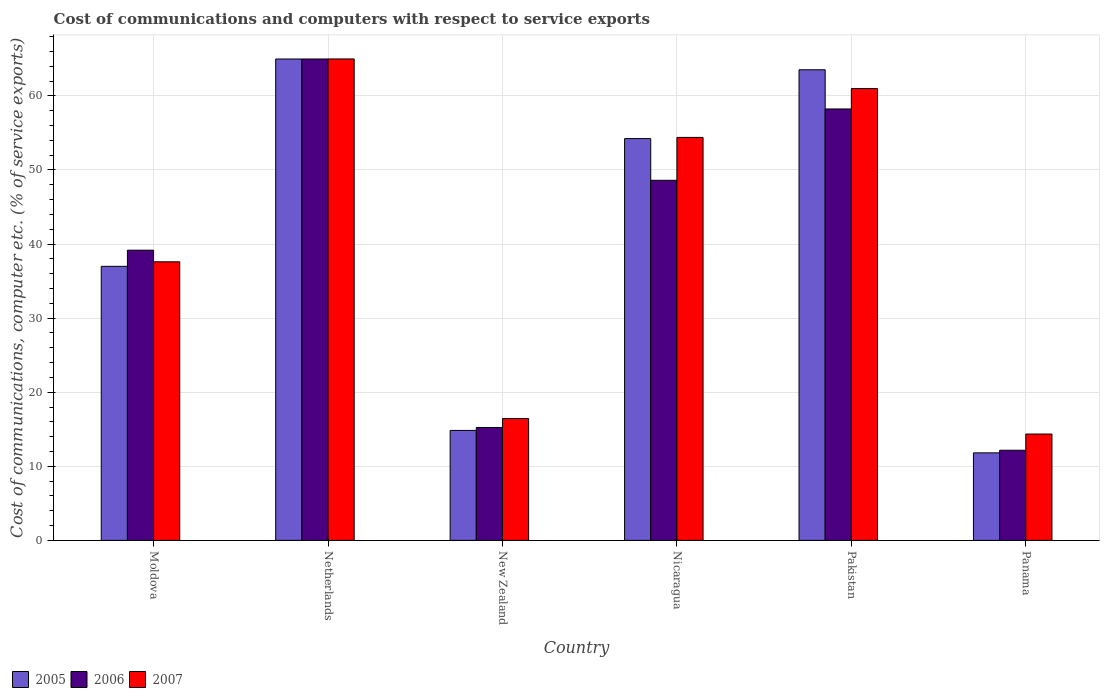How many different coloured bars are there?
Offer a terse response. 3. How many groups of bars are there?
Give a very brief answer. 6. Are the number of bars on each tick of the X-axis equal?
Offer a very short reply. Yes. How many bars are there on the 2nd tick from the left?
Give a very brief answer. 3. What is the label of the 4th group of bars from the left?
Keep it short and to the point. Nicaragua. In how many cases, is the number of bars for a given country not equal to the number of legend labels?
Make the answer very short. 0. What is the cost of communications and computers in 2007 in Panama?
Keep it short and to the point. 14.35. Across all countries, what is the maximum cost of communications and computers in 2005?
Offer a terse response. 64.97. Across all countries, what is the minimum cost of communications and computers in 2006?
Your answer should be compact. 12.17. In which country was the cost of communications and computers in 2005 minimum?
Provide a short and direct response. Panama. What is the total cost of communications and computers in 2005 in the graph?
Offer a terse response. 246.36. What is the difference between the cost of communications and computers in 2006 in Moldova and that in Panama?
Keep it short and to the point. 27. What is the difference between the cost of communications and computers in 2007 in Nicaragua and the cost of communications and computers in 2005 in Panama?
Make the answer very short. 42.57. What is the average cost of communications and computers in 2005 per country?
Your answer should be very brief. 41.06. What is the difference between the cost of communications and computers of/in 2006 and cost of communications and computers of/in 2005 in Nicaragua?
Offer a terse response. -5.63. In how many countries, is the cost of communications and computers in 2006 greater than 12 %?
Ensure brevity in your answer.  6. What is the ratio of the cost of communications and computers in 2006 in New Zealand to that in Panama?
Offer a terse response. 1.25. Is the difference between the cost of communications and computers in 2006 in Moldova and Netherlands greater than the difference between the cost of communications and computers in 2005 in Moldova and Netherlands?
Offer a very short reply. Yes. What is the difference between the highest and the second highest cost of communications and computers in 2007?
Your response must be concise. 4. What is the difference between the highest and the lowest cost of communications and computers in 2006?
Your answer should be very brief. 52.81. What does the 2nd bar from the right in Nicaragua represents?
Provide a short and direct response. 2006. How many bars are there?
Your answer should be compact. 18. Are all the bars in the graph horizontal?
Your response must be concise. No. Does the graph contain any zero values?
Your answer should be compact. No. Does the graph contain grids?
Your answer should be compact. Yes. What is the title of the graph?
Offer a very short reply. Cost of communications and computers with respect to service exports. What is the label or title of the X-axis?
Make the answer very short. Country. What is the label or title of the Y-axis?
Provide a short and direct response. Cost of communications, computer etc. (% of service exports). What is the Cost of communications, computer etc. (% of service exports) in 2005 in Moldova?
Ensure brevity in your answer.  36.99. What is the Cost of communications, computer etc. (% of service exports) of 2006 in Moldova?
Give a very brief answer. 39.17. What is the Cost of communications, computer etc. (% of service exports) of 2007 in Moldova?
Your answer should be very brief. 37.6. What is the Cost of communications, computer etc. (% of service exports) of 2005 in Netherlands?
Your response must be concise. 64.97. What is the Cost of communications, computer etc. (% of service exports) of 2006 in Netherlands?
Provide a succinct answer. 64.97. What is the Cost of communications, computer etc. (% of service exports) of 2007 in Netherlands?
Your response must be concise. 64.98. What is the Cost of communications, computer etc. (% of service exports) in 2005 in New Zealand?
Your answer should be very brief. 14.84. What is the Cost of communications, computer etc. (% of service exports) of 2006 in New Zealand?
Offer a terse response. 15.24. What is the Cost of communications, computer etc. (% of service exports) in 2007 in New Zealand?
Keep it short and to the point. 16.44. What is the Cost of communications, computer etc. (% of service exports) of 2005 in Nicaragua?
Your answer should be compact. 54.23. What is the Cost of communications, computer etc. (% of service exports) in 2006 in Nicaragua?
Keep it short and to the point. 48.6. What is the Cost of communications, computer etc. (% of service exports) in 2007 in Nicaragua?
Make the answer very short. 54.39. What is the Cost of communications, computer etc. (% of service exports) of 2005 in Pakistan?
Your answer should be compact. 63.52. What is the Cost of communications, computer etc. (% of service exports) of 2006 in Pakistan?
Offer a terse response. 58.23. What is the Cost of communications, computer etc. (% of service exports) of 2007 in Pakistan?
Provide a short and direct response. 60.98. What is the Cost of communications, computer etc. (% of service exports) in 2005 in Panama?
Provide a succinct answer. 11.81. What is the Cost of communications, computer etc. (% of service exports) in 2006 in Panama?
Provide a short and direct response. 12.17. What is the Cost of communications, computer etc. (% of service exports) in 2007 in Panama?
Your answer should be compact. 14.35. Across all countries, what is the maximum Cost of communications, computer etc. (% of service exports) in 2005?
Provide a short and direct response. 64.97. Across all countries, what is the maximum Cost of communications, computer etc. (% of service exports) of 2006?
Make the answer very short. 64.97. Across all countries, what is the maximum Cost of communications, computer etc. (% of service exports) of 2007?
Offer a terse response. 64.98. Across all countries, what is the minimum Cost of communications, computer etc. (% of service exports) in 2005?
Keep it short and to the point. 11.81. Across all countries, what is the minimum Cost of communications, computer etc. (% of service exports) of 2006?
Ensure brevity in your answer.  12.17. Across all countries, what is the minimum Cost of communications, computer etc. (% of service exports) of 2007?
Make the answer very short. 14.35. What is the total Cost of communications, computer etc. (% of service exports) in 2005 in the graph?
Your answer should be compact. 246.36. What is the total Cost of communications, computer etc. (% of service exports) in 2006 in the graph?
Your answer should be very brief. 238.37. What is the total Cost of communications, computer etc. (% of service exports) in 2007 in the graph?
Offer a terse response. 248.74. What is the difference between the Cost of communications, computer etc. (% of service exports) in 2005 in Moldova and that in Netherlands?
Your response must be concise. -27.98. What is the difference between the Cost of communications, computer etc. (% of service exports) in 2006 in Moldova and that in Netherlands?
Give a very brief answer. -25.81. What is the difference between the Cost of communications, computer etc. (% of service exports) in 2007 in Moldova and that in Netherlands?
Give a very brief answer. -27.38. What is the difference between the Cost of communications, computer etc. (% of service exports) of 2005 in Moldova and that in New Zealand?
Your response must be concise. 22.15. What is the difference between the Cost of communications, computer etc. (% of service exports) of 2006 in Moldova and that in New Zealand?
Give a very brief answer. 23.93. What is the difference between the Cost of communications, computer etc. (% of service exports) in 2007 in Moldova and that in New Zealand?
Make the answer very short. 21.16. What is the difference between the Cost of communications, computer etc. (% of service exports) of 2005 in Moldova and that in Nicaragua?
Offer a terse response. -17.24. What is the difference between the Cost of communications, computer etc. (% of service exports) of 2006 in Moldova and that in Nicaragua?
Provide a succinct answer. -9.43. What is the difference between the Cost of communications, computer etc. (% of service exports) of 2007 in Moldova and that in Nicaragua?
Ensure brevity in your answer.  -16.79. What is the difference between the Cost of communications, computer etc. (% of service exports) in 2005 in Moldova and that in Pakistan?
Make the answer very short. -26.53. What is the difference between the Cost of communications, computer etc. (% of service exports) of 2006 in Moldova and that in Pakistan?
Your answer should be compact. -19.06. What is the difference between the Cost of communications, computer etc. (% of service exports) in 2007 in Moldova and that in Pakistan?
Provide a short and direct response. -23.38. What is the difference between the Cost of communications, computer etc. (% of service exports) of 2005 in Moldova and that in Panama?
Ensure brevity in your answer.  25.17. What is the difference between the Cost of communications, computer etc. (% of service exports) in 2006 in Moldova and that in Panama?
Make the answer very short. 27. What is the difference between the Cost of communications, computer etc. (% of service exports) of 2007 in Moldova and that in Panama?
Your answer should be very brief. 23.25. What is the difference between the Cost of communications, computer etc. (% of service exports) of 2005 in Netherlands and that in New Zealand?
Your answer should be compact. 50.13. What is the difference between the Cost of communications, computer etc. (% of service exports) in 2006 in Netherlands and that in New Zealand?
Ensure brevity in your answer.  49.73. What is the difference between the Cost of communications, computer etc. (% of service exports) in 2007 in Netherlands and that in New Zealand?
Give a very brief answer. 48.54. What is the difference between the Cost of communications, computer etc. (% of service exports) in 2005 in Netherlands and that in Nicaragua?
Keep it short and to the point. 10.74. What is the difference between the Cost of communications, computer etc. (% of service exports) of 2006 in Netherlands and that in Nicaragua?
Give a very brief answer. 16.37. What is the difference between the Cost of communications, computer etc. (% of service exports) in 2007 in Netherlands and that in Nicaragua?
Provide a succinct answer. 10.59. What is the difference between the Cost of communications, computer etc. (% of service exports) in 2005 in Netherlands and that in Pakistan?
Keep it short and to the point. 1.45. What is the difference between the Cost of communications, computer etc. (% of service exports) in 2006 in Netherlands and that in Pakistan?
Provide a short and direct response. 6.75. What is the difference between the Cost of communications, computer etc. (% of service exports) of 2007 in Netherlands and that in Pakistan?
Give a very brief answer. 4. What is the difference between the Cost of communications, computer etc. (% of service exports) in 2005 in Netherlands and that in Panama?
Offer a terse response. 53.16. What is the difference between the Cost of communications, computer etc. (% of service exports) in 2006 in Netherlands and that in Panama?
Your response must be concise. 52.81. What is the difference between the Cost of communications, computer etc. (% of service exports) of 2007 in Netherlands and that in Panama?
Keep it short and to the point. 50.62. What is the difference between the Cost of communications, computer etc. (% of service exports) in 2005 in New Zealand and that in Nicaragua?
Provide a succinct answer. -39.39. What is the difference between the Cost of communications, computer etc. (% of service exports) of 2006 in New Zealand and that in Nicaragua?
Ensure brevity in your answer.  -33.36. What is the difference between the Cost of communications, computer etc. (% of service exports) of 2007 in New Zealand and that in Nicaragua?
Provide a succinct answer. -37.95. What is the difference between the Cost of communications, computer etc. (% of service exports) in 2005 in New Zealand and that in Pakistan?
Make the answer very short. -48.68. What is the difference between the Cost of communications, computer etc. (% of service exports) of 2006 in New Zealand and that in Pakistan?
Make the answer very short. -42.99. What is the difference between the Cost of communications, computer etc. (% of service exports) in 2007 in New Zealand and that in Pakistan?
Offer a terse response. -44.54. What is the difference between the Cost of communications, computer etc. (% of service exports) in 2005 in New Zealand and that in Panama?
Offer a terse response. 3.03. What is the difference between the Cost of communications, computer etc. (% of service exports) of 2006 in New Zealand and that in Panama?
Offer a terse response. 3.07. What is the difference between the Cost of communications, computer etc. (% of service exports) in 2007 in New Zealand and that in Panama?
Keep it short and to the point. 2.09. What is the difference between the Cost of communications, computer etc. (% of service exports) in 2005 in Nicaragua and that in Pakistan?
Keep it short and to the point. -9.29. What is the difference between the Cost of communications, computer etc. (% of service exports) in 2006 in Nicaragua and that in Pakistan?
Offer a terse response. -9.63. What is the difference between the Cost of communications, computer etc. (% of service exports) of 2007 in Nicaragua and that in Pakistan?
Offer a terse response. -6.6. What is the difference between the Cost of communications, computer etc. (% of service exports) of 2005 in Nicaragua and that in Panama?
Your answer should be very brief. 42.42. What is the difference between the Cost of communications, computer etc. (% of service exports) in 2006 in Nicaragua and that in Panama?
Provide a succinct answer. 36.43. What is the difference between the Cost of communications, computer etc. (% of service exports) of 2007 in Nicaragua and that in Panama?
Provide a succinct answer. 40.03. What is the difference between the Cost of communications, computer etc. (% of service exports) in 2005 in Pakistan and that in Panama?
Ensure brevity in your answer.  51.71. What is the difference between the Cost of communications, computer etc. (% of service exports) of 2006 in Pakistan and that in Panama?
Your response must be concise. 46.06. What is the difference between the Cost of communications, computer etc. (% of service exports) of 2007 in Pakistan and that in Panama?
Provide a short and direct response. 46.63. What is the difference between the Cost of communications, computer etc. (% of service exports) in 2005 in Moldova and the Cost of communications, computer etc. (% of service exports) in 2006 in Netherlands?
Keep it short and to the point. -27.99. What is the difference between the Cost of communications, computer etc. (% of service exports) in 2005 in Moldova and the Cost of communications, computer etc. (% of service exports) in 2007 in Netherlands?
Keep it short and to the point. -27.99. What is the difference between the Cost of communications, computer etc. (% of service exports) in 2006 in Moldova and the Cost of communications, computer etc. (% of service exports) in 2007 in Netherlands?
Your answer should be very brief. -25.81. What is the difference between the Cost of communications, computer etc. (% of service exports) in 2005 in Moldova and the Cost of communications, computer etc. (% of service exports) in 2006 in New Zealand?
Your answer should be compact. 21.75. What is the difference between the Cost of communications, computer etc. (% of service exports) of 2005 in Moldova and the Cost of communications, computer etc. (% of service exports) of 2007 in New Zealand?
Ensure brevity in your answer.  20.55. What is the difference between the Cost of communications, computer etc. (% of service exports) in 2006 in Moldova and the Cost of communications, computer etc. (% of service exports) in 2007 in New Zealand?
Your response must be concise. 22.73. What is the difference between the Cost of communications, computer etc. (% of service exports) of 2005 in Moldova and the Cost of communications, computer etc. (% of service exports) of 2006 in Nicaragua?
Provide a short and direct response. -11.61. What is the difference between the Cost of communications, computer etc. (% of service exports) of 2005 in Moldova and the Cost of communications, computer etc. (% of service exports) of 2007 in Nicaragua?
Offer a terse response. -17.4. What is the difference between the Cost of communications, computer etc. (% of service exports) in 2006 in Moldova and the Cost of communications, computer etc. (% of service exports) in 2007 in Nicaragua?
Provide a short and direct response. -15.22. What is the difference between the Cost of communications, computer etc. (% of service exports) in 2005 in Moldova and the Cost of communications, computer etc. (% of service exports) in 2006 in Pakistan?
Offer a terse response. -21.24. What is the difference between the Cost of communications, computer etc. (% of service exports) of 2005 in Moldova and the Cost of communications, computer etc. (% of service exports) of 2007 in Pakistan?
Your response must be concise. -24. What is the difference between the Cost of communications, computer etc. (% of service exports) of 2006 in Moldova and the Cost of communications, computer etc. (% of service exports) of 2007 in Pakistan?
Offer a very short reply. -21.82. What is the difference between the Cost of communications, computer etc. (% of service exports) in 2005 in Moldova and the Cost of communications, computer etc. (% of service exports) in 2006 in Panama?
Provide a short and direct response. 24.82. What is the difference between the Cost of communications, computer etc. (% of service exports) in 2005 in Moldova and the Cost of communications, computer etc. (% of service exports) in 2007 in Panama?
Your response must be concise. 22.63. What is the difference between the Cost of communications, computer etc. (% of service exports) of 2006 in Moldova and the Cost of communications, computer etc. (% of service exports) of 2007 in Panama?
Provide a short and direct response. 24.81. What is the difference between the Cost of communications, computer etc. (% of service exports) in 2005 in Netherlands and the Cost of communications, computer etc. (% of service exports) in 2006 in New Zealand?
Keep it short and to the point. 49.73. What is the difference between the Cost of communications, computer etc. (% of service exports) in 2005 in Netherlands and the Cost of communications, computer etc. (% of service exports) in 2007 in New Zealand?
Provide a short and direct response. 48.53. What is the difference between the Cost of communications, computer etc. (% of service exports) in 2006 in Netherlands and the Cost of communications, computer etc. (% of service exports) in 2007 in New Zealand?
Your answer should be compact. 48.53. What is the difference between the Cost of communications, computer etc. (% of service exports) of 2005 in Netherlands and the Cost of communications, computer etc. (% of service exports) of 2006 in Nicaragua?
Give a very brief answer. 16.37. What is the difference between the Cost of communications, computer etc. (% of service exports) in 2005 in Netherlands and the Cost of communications, computer etc. (% of service exports) in 2007 in Nicaragua?
Give a very brief answer. 10.58. What is the difference between the Cost of communications, computer etc. (% of service exports) of 2006 in Netherlands and the Cost of communications, computer etc. (% of service exports) of 2007 in Nicaragua?
Offer a terse response. 10.59. What is the difference between the Cost of communications, computer etc. (% of service exports) in 2005 in Netherlands and the Cost of communications, computer etc. (% of service exports) in 2006 in Pakistan?
Your response must be concise. 6.74. What is the difference between the Cost of communications, computer etc. (% of service exports) of 2005 in Netherlands and the Cost of communications, computer etc. (% of service exports) of 2007 in Pakistan?
Your answer should be very brief. 3.99. What is the difference between the Cost of communications, computer etc. (% of service exports) of 2006 in Netherlands and the Cost of communications, computer etc. (% of service exports) of 2007 in Pakistan?
Your answer should be very brief. 3.99. What is the difference between the Cost of communications, computer etc. (% of service exports) in 2005 in Netherlands and the Cost of communications, computer etc. (% of service exports) in 2006 in Panama?
Your response must be concise. 52.81. What is the difference between the Cost of communications, computer etc. (% of service exports) of 2005 in Netherlands and the Cost of communications, computer etc. (% of service exports) of 2007 in Panama?
Offer a very short reply. 50.62. What is the difference between the Cost of communications, computer etc. (% of service exports) of 2006 in Netherlands and the Cost of communications, computer etc. (% of service exports) of 2007 in Panama?
Your response must be concise. 50.62. What is the difference between the Cost of communications, computer etc. (% of service exports) in 2005 in New Zealand and the Cost of communications, computer etc. (% of service exports) in 2006 in Nicaragua?
Your response must be concise. -33.76. What is the difference between the Cost of communications, computer etc. (% of service exports) of 2005 in New Zealand and the Cost of communications, computer etc. (% of service exports) of 2007 in Nicaragua?
Your answer should be very brief. -39.55. What is the difference between the Cost of communications, computer etc. (% of service exports) in 2006 in New Zealand and the Cost of communications, computer etc. (% of service exports) in 2007 in Nicaragua?
Your answer should be very brief. -39.15. What is the difference between the Cost of communications, computer etc. (% of service exports) in 2005 in New Zealand and the Cost of communications, computer etc. (% of service exports) in 2006 in Pakistan?
Offer a terse response. -43.39. What is the difference between the Cost of communications, computer etc. (% of service exports) of 2005 in New Zealand and the Cost of communications, computer etc. (% of service exports) of 2007 in Pakistan?
Provide a succinct answer. -46.14. What is the difference between the Cost of communications, computer etc. (% of service exports) of 2006 in New Zealand and the Cost of communications, computer etc. (% of service exports) of 2007 in Pakistan?
Give a very brief answer. -45.74. What is the difference between the Cost of communications, computer etc. (% of service exports) in 2005 in New Zealand and the Cost of communications, computer etc. (% of service exports) in 2006 in Panama?
Offer a terse response. 2.68. What is the difference between the Cost of communications, computer etc. (% of service exports) in 2005 in New Zealand and the Cost of communications, computer etc. (% of service exports) in 2007 in Panama?
Your answer should be compact. 0.49. What is the difference between the Cost of communications, computer etc. (% of service exports) of 2006 in New Zealand and the Cost of communications, computer etc. (% of service exports) of 2007 in Panama?
Offer a very short reply. 0.89. What is the difference between the Cost of communications, computer etc. (% of service exports) in 2005 in Nicaragua and the Cost of communications, computer etc. (% of service exports) in 2006 in Pakistan?
Provide a short and direct response. -4. What is the difference between the Cost of communications, computer etc. (% of service exports) of 2005 in Nicaragua and the Cost of communications, computer etc. (% of service exports) of 2007 in Pakistan?
Keep it short and to the point. -6.75. What is the difference between the Cost of communications, computer etc. (% of service exports) in 2006 in Nicaragua and the Cost of communications, computer etc. (% of service exports) in 2007 in Pakistan?
Your response must be concise. -12.38. What is the difference between the Cost of communications, computer etc. (% of service exports) of 2005 in Nicaragua and the Cost of communications, computer etc. (% of service exports) of 2006 in Panama?
Your response must be concise. 42.06. What is the difference between the Cost of communications, computer etc. (% of service exports) in 2005 in Nicaragua and the Cost of communications, computer etc. (% of service exports) in 2007 in Panama?
Offer a very short reply. 39.88. What is the difference between the Cost of communications, computer etc. (% of service exports) in 2006 in Nicaragua and the Cost of communications, computer etc. (% of service exports) in 2007 in Panama?
Keep it short and to the point. 34.24. What is the difference between the Cost of communications, computer etc. (% of service exports) in 2005 in Pakistan and the Cost of communications, computer etc. (% of service exports) in 2006 in Panama?
Ensure brevity in your answer.  51.35. What is the difference between the Cost of communications, computer etc. (% of service exports) in 2005 in Pakistan and the Cost of communications, computer etc. (% of service exports) in 2007 in Panama?
Your answer should be very brief. 49.17. What is the difference between the Cost of communications, computer etc. (% of service exports) in 2006 in Pakistan and the Cost of communications, computer etc. (% of service exports) in 2007 in Panama?
Give a very brief answer. 43.87. What is the average Cost of communications, computer etc. (% of service exports) of 2005 per country?
Make the answer very short. 41.06. What is the average Cost of communications, computer etc. (% of service exports) in 2006 per country?
Offer a very short reply. 39.73. What is the average Cost of communications, computer etc. (% of service exports) in 2007 per country?
Your answer should be very brief. 41.46. What is the difference between the Cost of communications, computer etc. (% of service exports) of 2005 and Cost of communications, computer etc. (% of service exports) of 2006 in Moldova?
Provide a succinct answer. -2.18. What is the difference between the Cost of communications, computer etc. (% of service exports) in 2005 and Cost of communications, computer etc. (% of service exports) in 2007 in Moldova?
Ensure brevity in your answer.  -0.61. What is the difference between the Cost of communications, computer etc. (% of service exports) of 2006 and Cost of communications, computer etc. (% of service exports) of 2007 in Moldova?
Your answer should be very brief. 1.57. What is the difference between the Cost of communications, computer etc. (% of service exports) in 2005 and Cost of communications, computer etc. (% of service exports) in 2006 in Netherlands?
Give a very brief answer. -0. What is the difference between the Cost of communications, computer etc. (% of service exports) of 2005 and Cost of communications, computer etc. (% of service exports) of 2007 in Netherlands?
Give a very brief answer. -0.01. What is the difference between the Cost of communications, computer etc. (% of service exports) of 2006 and Cost of communications, computer etc. (% of service exports) of 2007 in Netherlands?
Provide a succinct answer. -0.01. What is the difference between the Cost of communications, computer etc. (% of service exports) in 2005 and Cost of communications, computer etc. (% of service exports) in 2006 in New Zealand?
Your response must be concise. -0.4. What is the difference between the Cost of communications, computer etc. (% of service exports) of 2005 and Cost of communications, computer etc. (% of service exports) of 2007 in New Zealand?
Provide a succinct answer. -1.6. What is the difference between the Cost of communications, computer etc. (% of service exports) of 2006 and Cost of communications, computer etc. (% of service exports) of 2007 in New Zealand?
Provide a short and direct response. -1.2. What is the difference between the Cost of communications, computer etc. (% of service exports) in 2005 and Cost of communications, computer etc. (% of service exports) in 2006 in Nicaragua?
Make the answer very short. 5.63. What is the difference between the Cost of communications, computer etc. (% of service exports) in 2005 and Cost of communications, computer etc. (% of service exports) in 2007 in Nicaragua?
Your answer should be very brief. -0.16. What is the difference between the Cost of communications, computer etc. (% of service exports) of 2006 and Cost of communications, computer etc. (% of service exports) of 2007 in Nicaragua?
Offer a terse response. -5.79. What is the difference between the Cost of communications, computer etc. (% of service exports) in 2005 and Cost of communications, computer etc. (% of service exports) in 2006 in Pakistan?
Offer a terse response. 5.29. What is the difference between the Cost of communications, computer etc. (% of service exports) in 2005 and Cost of communications, computer etc. (% of service exports) in 2007 in Pakistan?
Offer a very short reply. 2.54. What is the difference between the Cost of communications, computer etc. (% of service exports) in 2006 and Cost of communications, computer etc. (% of service exports) in 2007 in Pakistan?
Your response must be concise. -2.76. What is the difference between the Cost of communications, computer etc. (% of service exports) in 2005 and Cost of communications, computer etc. (% of service exports) in 2006 in Panama?
Offer a terse response. -0.35. What is the difference between the Cost of communications, computer etc. (% of service exports) in 2005 and Cost of communications, computer etc. (% of service exports) in 2007 in Panama?
Your response must be concise. -2.54. What is the difference between the Cost of communications, computer etc. (% of service exports) of 2006 and Cost of communications, computer etc. (% of service exports) of 2007 in Panama?
Your response must be concise. -2.19. What is the ratio of the Cost of communications, computer etc. (% of service exports) in 2005 in Moldova to that in Netherlands?
Give a very brief answer. 0.57. What is the ratio of the Cost of communications, computer etc. (% of service exports) in 2006 in Moldova to that in Netherlands?
Your answer should be compact. 0.6. What is the ratio of the Cost of communications, computer etc. (% of service exports) in 2007 in Moldova to that in Netherlands?
Offer a very short reply. 0.58. What is the ratio of the Cost of communications, computer etc. (% of service exports) in 2005 in Moldova to that in New Zealand?
Make the answer very short. 2.49. What is the ratio of the Cost of communications, computer etc. (% of service exports) of 2006 in Moldova to that in New Zealand?
Provide a short and direct response. 2.57. What is the ratio of the Cost of communications, computer etc. (% of service exports) in 2007 in Moldova to that in New Zealand?
Your answer should be very brief. 2.29. What is the ratio of the Cost of communications, computer etc. (% of service exports) of 2005 in Moldova to that in Nicaragua?
Your answer should be compact. 0.68. What is the ratio of the Cost of communications, computer etc. (% of service exports) in 2006 in Moldova to that in Nicaragua?
Keep it short and to the point. 0.81. What is the ratio of the Cost of communications, computer etc. (% of service exports) of 2007 in Moldova to that in Nicaragua?
Provide a short and direct response. 0.69. What is the ratio of the Cost of communications, computer etc. (% of service exports) in 2005 in Moldova to that in Pakistan?
Keep it short and to the point. 0.58. What is the ratio of the Cost of communications, computer etc. (% of service exports) in 2006 in Moldova to that in Pakistan?
Your response must be concise. 0.67. What is the ratio of the Cost of communications, computer etc. (% of service exports) in 2007 in Moldova to that in Pakistan?
Provide a succinct answer. 0.62. What is the ratio of the Cost of communications, computer etc. (% of service exports) in 2005 in Moldova to that in Panama?
Offer a very short reply. 3.13. What is the ratio of the Cost of communications, computer etc. (% of service exports) of 2006 in Moldova to that in Panama?
Your answer should be compact. 3.22. What is the ratio of the Cost of communications, computer etc. (% of service exports) in 2007 in Moldova to that in Panama?
Give a very brief answer. 2.62. What is the ratio of the Cost of communications, computer etc. (% of service exports) of 2005 in Netherlands to that in New Zealand?
Offer a terse response. 4.38. What is the ratio of the Cost of communications, computer etc. (% of service exports) of 2006 in Netherlands to that in New Zealand?
Provide a short and direct response. 4.26. What is the ratio of the Cost of communications, computer etc. (% of service exports) of 2007 in Netherlands to that in New Zealand?
Your response must be concise. 3.95. What is the ratio of the Cost of communications, computer etc. (% of service exports) in 2005 in Netherlands to that in Nicaragua?
Provide a succinct answer. 1.2. What is the ratio of the Cost of communications, computer etc. (% of service exports) in 2006 in Netherlands to that in Nicaragua?
Ensure brevity in your answer.  1.34. What is the ratio of the Cost of communications, computer etc. (% of service exports) in 2007 in Netherlands to that in Nicaragua?
Keep it short and to the point. 1.19. What is the ratio of the Cost of communications, computer etc. (% of service exports) of 2005 in Netherlands to that in Pakistan?
Your answer should be very brief. 1.02. What is the ratio of the Cost of communications, computer etc. (% of service exports) in 2006 in Netherlands to that in Pakistan?
Ensure brevity in your answer.  1.12. What is the ratio of the Cost of communications, computer etc. (% of service exports) in 2007 in Netherlands to that in Pakistan?
Your answer should be compact. 1.07. What is the ratio of the Cost of communications, computer etc. (% of service exports) of 2005 in Netherlands to that in Panama?
Your response must be concise. 5.5. What is the ratio of the Cost of communications, computer etc. (% of service exports) in 2006 in Netherlands to that in Panama?
Make the answer very short. 5.34. What is the ratio of the Cost of communications, computer etc. (% of service exports) of 2007 in Netherlands to that in Panama?
Make the answer very short. 4.53. What is the ratio of the Cost of communications, computer etc. (% of service exports) of 2005 in New Zealand to that in Nicaragua?
Your answer should be compact. 0.27. What is the ratio of the Cost of communications, computer etc. (% of service exports) of 2006 in New Zealand to that in Nicaragua?
Your answer should be compact. 0.31. What is the ratio of the Cost of communications, computer etc. (% of service exports) in 2007 in New Zealand to that in Nicaragua?
Keep it short and to the point. 0.3. What is the ratio of the Cost of communications, computer etc. (% of service exports) of 2005 in New Zealand to that in Pakistan?
Provide a succinct answer. 0.23. What is the ratio of the Cost of communications, computer etc. (% of service exports) in 2006 in New Zealand to that in Pakistan?
Provide a short and direct response. 0.26. What is the ratio of the Cost of communications, computer etc. (% of service exports) in 2007 in New Zealand to that in Pakistan?
Give a very brief answer. 0.27. What is the ratio of the Cost of communications, computer etc. (% of service exports) in 2005 in New Zealand to that in Panama?
Provide a short and direct response. 1.26. What is the ratio of the Cost of communications, computer etc. (% of service exports) in 2006 in New Zealand to that in Panama?
Keep it short and to the point. 1.25. What is the ratio of the Cost of communications, computer etc. (% of service exports) in 2007 in New Zealand to that in Panama?
Your answer should be very brief. 1.15. What is the ratio of the Cost of communications, computer etc. (% of service exports) of 2005 in Nicaragua to that in Pakistan?
Make the answer very short. 0.85. What is the ratio of the Cost of communications, computer etc. (% of service exports) of 2006 in Nicaragua to that in Pakistan?
Give a very brief answer. 0.83. What is the ratio of the Cost of communications, computer etc. (% of service exports) in 2007 in Nicaragua to that in Pakistan?
Keep it short and to the point. 0.89. What is the ratio of the Cost of communications, computer etc. (% of service exports) of 2005 in Nicaragua to that in Panama?
Provide a succinct answer. 4.59. What is the ratio of the Cost of communications, computer etc. (% of service exports) of 2006 in Nicaragua to that in Panama?
Provide a short and direct response. 3.99. What is the ratio of the Cost of communications, computer etc. (% of service exports) of 2007 in Nicaragua to that in Panama?
Provide a succinct answer. 3.79. What is the ratio of the Cost of communications, computer etc. (% of service exports) of 2005 in Pakistan to that in Panama?
Offer a very short reply. 5.38. What is the ratio of the Cost of communications, computer etc. (% of service exports) of 2006 in Pakistan to that in Panama?
Offer a very short reply. 4.79. What is the ratio of the Cost of communications, computer etc. (% of service exports) of 2007 in Pakistan to that in Panama?
Ensure brevity in your answer.  4.25. What is the difference between the highest and the second highest Cost of communications, computer etc. (% of service exports) of 2005?
Provide a short and direct response. 1.45. What is the difference between the highest and the second highest Cost of communications, computer etc. (% of service exports) of 2006?
Give a very brief answer. 6.75. What is the difference between the highest and the second highest Cost of communications, computer etc. (% of service exports) in 2007?
Offer a terse response. 4. What is the difference between the highest and the lowest Cost of communications, computer etc. (% of service exports) of 2005?
Make the answer very short. 53.16. What is the difference between the highest and the lowest Cost of communications, computer etc. (% of service exports) of 2006?
Offer a very short reply. 52.81. What is the difference between the highest and the lowest Cost of communications, computer etc. (% of service exports) of 2007?
Provide a succinct answer. 50.62. 